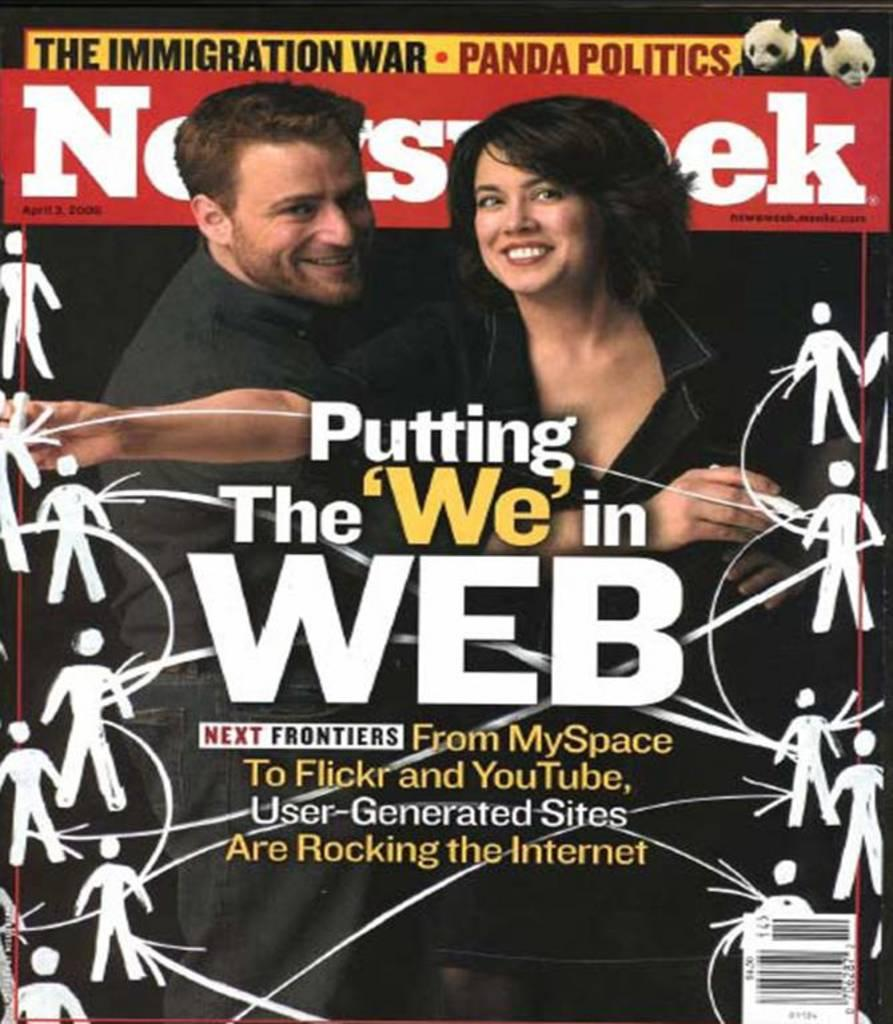What type of visual content is the image? The image is a poster. What people are depicted in the poster? There is a man and a woman smiling in the poster. What additional elements are present on the poster? There are letters and a barcode on the poster. Can you describe the design on the poster? There is a design on the poster, but the specifics are not mentioned in the facts. What type of invention is shown in the poster? There is no invention depicted in the poster; it features a man, a woman, letters, a barcode, and a design. What season is it in the poster? The facts do not mention any season or weather-related details, so it cannot be determined from the image. 